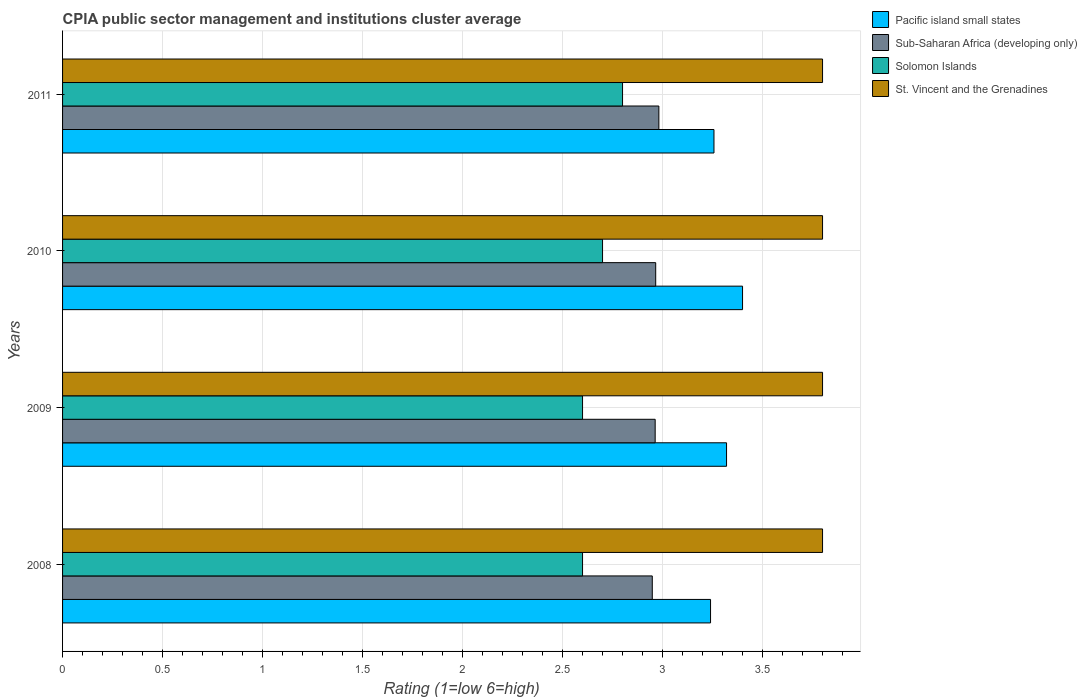How many groups of bars are there?
Your answer should be very brief. 4. Are the number of bars on each tick of the Y-axis equal?
Your response must be concise. Yes. How many bars are there on the 2nd tick from the bottom?
Ensure brevity in your answer.  4. What is the label of the 3rd group of bars from the top?
Offer a terse response. 2009. In how many cases, is the number of bars for a given year not equal to the number of legend labels?
Make the answer very short. 0. What is the CPIA rating in Solomon Islands in 2009?
Ensure brevity in your answer.  2.6. Across all years, what is the maximum CPIA rating in Solomon Islands?
Offer a very short reply. 2.8. Across all years, what is the minimum CPIA rating in Sub-Saharan Africa (developing only)?
Ensure brevity in your answer.  2.95. In which year was the CPIA rating in St. Vincent and the Grenadines minimum?
Keep it short and to the point. 2008. What is the total CPIA rating in Sub-Saharan Africa (developing only) in the graph?
Give a very brief answer. 11.86. What is the difference between the CPIA rating in Sub-Saharan Africa (developing only) in 2009 and that in 2010?
Ensure brevity in your answer.  -0. What is the difference between the CPIA rating in Pacific island small states in 2009 and the CPIA rating in Sub-Saharan Africa (developing only) in 2008?
Give a very brief answer. 0.37. What is the average CPIA rating in Sub-Saharan Africa (developing only) per year?
Your answer should be very brief. 2.96. In the year 2009, what is the difference between the CPIA rating in Pacific island small states and CPIA rating in Solomon Islands?
Your response must be concise. 0.72. What is the ratio of the CPIA rating in Solomon Islands in 2009 to that in 2010?
Give a very brief answer. 0.96. Is the difference between the CPIA rating in Pacific island small states in 2010 and 2011 greater than the difference between the CPIA rating in Solomon Islands in 2010 and 2011?
Your response must be concise. Yes. What is the difference between the highest and the second highest CPIA rating in Pacific island small states?
Keep it short and to the point. 0.08. What is the difference between the highest and the lowest CPIA rating in St. Vincent and the Grenadines?
Your response must be concise. 0. Is the sum of the CPIA rating in Pacific island small states in 2009 and 2010 greater than the maximum CPIA rating in Sub-Saharan Africa (developing only) across all years?
Your answer should be very brief. Yes. What does the 3rd bar from the top in 2010 represents?
Give a very brief answer. Sub-Saharan Africa (developing only). What does the 3rd bar from the bottom in 2009 represents?
Make the answer very short. Solomon Islands. Is it the case that in every year, the sum of the CPIA rating in Sub-Saharan Africa (developing only) and CPIA rating in St. Vincent and the Grenadines is greater than the CPIA rating in Pacific island small states?
Give a very brief answer. Yes. How many bars are there?
Provide a short and direct response. 16. Are all the bars in the graph horizontal?
Give a very brief answer. Yes. How many years are there in the graph?
Your response must be concise. 4. What is the difference between two consecutive major ticks on the X-axis?
Provide a succinct answer. 0.5. Does the graph contain grids?
Keep it short and to the point. Yes. How are the legend labels stacked?
Provide a succinct answer. Vertical. What is the title of the graph?
Your answer should be very brief. CPIA public sector management and institutions cluster average. What is the label or title of the Y-axis?
Keep it short and to the point. Years. What is the Rating (1=low 6=high) in Pacific island small states in 2008?
Your answer should be compact. 3.24. What is the Rating (1=low 6=high) in Sub-Saharan Africa (developing only) in 2008?
Make the answer very short. 2.95. What is the Rating (1=low 6=high) of Solomon Islands in 2008?
Make the answer very short. 2.6. What is the Rating (1=low 6=high) in St. Vincent and the Grenadines in 2008?
Provide a succinct answer. 3.8. What is the Rating (1=low 6=high) in Pacific island small states in 2009?
Your response must be concise. 3.32. What is the Rating (1=low 6=high) in Sub-Saharan Africa (developing only) in 2009?
Provide a short and direct response. 2.96. What is the Rating (1=low 6=high) of St. Vincent and the Grenadines in 2009?
Your response must be concise. 3.8. What is the Rating (1=low 6=high) in Pacific island small states in 2010?
Give a very brief answer. 3.4. What is the Rating (1=low 6=high) in Sub-Saharan Africa (developing only) in 2010?
Your answer should be very brief. 2.97. What is the Rating (1=low 6=high) of St. Vincent and the Grenadines in 2010?
Your answer should be compact. 3.8. What is the Rating (1=low 6=high) in Pacific island small states in 2011?
Provide a short and direct response. 3.26. What is the Rating (1=low 6=high) in Sub-Saharan Africa (developing only) in 2011?
Make the answer very short. 2.98. What is the Rating (1=low 6=high) of Solomon Islands in 2011?
Offer a very short reply. 2.8. Across all years, what is the maximum Rating (1=low 6=high) of Pacific island small states?
Provide a succinct answer. 3.4. Across all years, what is the maximum Rating (1=low 6=high) of Sub-Saharan Africa (developing only)?
Your response must be concise. 2.98. Across all years, what is the maximum Rating (1=low 6=high) in St. Vincent and the Grenadines?
Provide a short and direct response. 3.8. Across all years, what is the minimum Rating (1=low 6=high) of Pacific island small states?
Your answer should be compact. 3.24. Across all years, what is the minimum Rating (1=low 6=high) in Sub-Saharan Africa (developing only)?
Keep it short and to the point. 2.95. Across all years, what is the minimum Rating (1=low 6=high) of St. Vincent and the Grenadines?
Offer a terse response. 3.8. What is the total Rating (1=low 6=high) in Pacific island small states in the graph?
Make the answer very short. 13.22. What is the total Rating (1=low 6=high) in Sub-Saharan Africa (developing only) in the graph?
Make the answer very short. 11.86. What is the total Rating (1=low 6=high) in Solomon Islands in the graph?
Ensure brevity in your answer.  10.7. What is the total Rating (1=low 6=high) in St. Vincent and the Grenadines in the graph?
Provide a succinct answer. 15.2. What is the difference between the Rating (1=low 6=high) in Pacific island small states in 2008 and that in 2009?
Keep it short and to the point. -0.08. What is the difference between the Rating (1=low 6=high) of Sub-Saharan Africa (developing only) in 2008 and that in 2009?
Your answer should be compact. -0.01. What is the difference between the Rating (1=low 6=high) in Pacific island small states in 2008 and that in 2010?
Offer a very short reply. -0.16. What is the difference between the Rating (1=low 6=high) of Sub-Saharan Africa (developing only) in 2008 and that in 2010?
Offer a terse response. -0.02. What is the difference between the Rating (1=low 6=high) of Solomon Islands in 2008 and that in 2010?
Provide a succinct answer. -0.1. What is the difference between the Rating (1=low 6=high) of Pacific island small states in 2008 and that in 2011?
Make the answer very short. -0.02. What is the difference between the Rating (1=low 6=high) of Sub-Saharan Africa (developing only) in 2008 and that in 2011?
Your answer should be very brief. -0.03. What is the difference between the Rating (1=low 6=high) of St. Vincent and the Grenadines in 2008 and that in 2011?
Ensure brevity in your answer.  0. What is the difference between the Rating (1=low 6=high) in Pacific island small states in 2009 and that in 2010?
Provide a short and direct response. -0.08. What is the difference between the Rating (1=low 6=high) of Sub-Saharan Africa (developing only) in 2009 and that in 2010?
Your answer should be very brief. -0. What is the difference between the Rating (1=low 6=high) of Solomon Islands in 2009 and that in 2010?
Provide a succinct answer. -0.1. What is the difference between the Rating (1=low 6=high) of St. Vincent and the Grenadines in 2009 and that in 2010?
Your response must be concise. 0. What is the difference between the Rating (1=low 6=high) of Pacific island small states in 2009 and that in 2011?
Provide a short and direct response. 0.06. What is the difference between the Rating (1=low 6=high) in Sub-Saharan Africa (developing only) in 2009 and that in 2011?
Provide a succinct answer. -0.02. What is the difference between the Rating (1=low 6=high) of St. Vincent and the Grenadines in 2009 and that in 2011?
Your answer should be very brief. 0. What is the difference between the Rating (1=low 6=high) in Pacific island small states in 2010 and that in 2011?
Offer a terse response. 0.14. What is the difference between the Rating (1=low 6=high) of Sub-Saharan Africa (developing only) in 2010 and that in 2011?
Give a very brief answer. -0.02. What is the difference between the Rating (1=low 6=high) of Solomon Islands in 2010 and that in 2011?
Make the answer very short. -0.1. What is the difference between the Rating (1=low 6=high) in Pacific island small states in 2008 and the Rating (1=low 6=high) in Sub-Saharan Africa (developing only) in 2009?
Provide a short and direct response. 0.28. What is the difference between the Rating (1=low 6=high) of Pacific island small states in 2008 and the Rating (1=low 6=high) of Solomon Islands in 2009?
Offer a terse response. 0.64. What is the difference between the Rating (1=low 6=high) in Pacific island small states in 2008 and the Rating (1=low 6=high) in St. Vincent and the Grenadines in 2009?
Provide a succinct answer. -0.56. What is the difference between the Rating (1=low 6=high) of Sub-Saharan Africa (developing only) in 2008 and the Rating (1=low 6=high) of Solomon Islands in 2009?
Your answer should be very brief. 0.35. What is the difference between the Rating (1=low 6=high) of Sub-Saharan Africa (developing only) in 2008 and the Rating (1=low 6=high) of St. Vincent and the Grenadines in 2009?
Your response must be concise. -0.85. What is the difference between the Rating (1=low 6=high) in Solomon Islands in 2008 and the Rating (1=low 6=high) in St. Vincent and the Grenadines in 2009?
Your response must be concise. -1.2. What is the difference between the Rating (1=low 6=high) of Pacific island small states in 2008 and the Rating (1=low 6=high) of Sub-Saharan Africa (developing only) in 2010?
Give a very brief answer. 0.27. What is the difference between the Rating (1=low 6=high) in Pacific island small states in 2008 and the Rating (1=low 6=high) in Solomon Islands in 2010?
Provide a succinct answer. 0.54. What is the difference between the Rating (1=low 6=high) of Pacific island small states in 2008 and the Rating (1=low 6=high) of St. Vincent and the Grenadines in 2010?
Give a very brief answer. -0.56. What is the difference between the Rating (1=low 6=high) in Sub-Saharan Africa (developing only) in 2008 and the Rating (1=low 6=high) in Solomon Islands in 2010?
Offer a terse response. 0.25. What is the difference between the Rating (1=low 6=high) in Sub-Saharan Africa (developing only) in 2008 and the Rating (1=low 6=high) in St. Vincent and the Grenadines in 2010?
Keep it short and to the point. -0.85. What is the difference between the Rating (1=low 6=high) of Pacific island small states in 2008 and the Rating (1=low 6=high) of Sub-Saharan Africa (developing only) in 2011?
Give a very brief answer. 0.26. What is the difference between the Rating (1=low 6=high) in Pacific island small states in 2008 and the Rating (1=low 6=high) in Solomon Islands in 2011?
Make the answer very short. 0.44. What is the difference between the Rating (1=low 6=high) of Pacific island small states in 2008 and the Rating (1=low 6=high) of St. Vincent and the Grenadines in 2011?
Your answer should be very brief. -0.56. What is the difference between the Rating (1=low 6=high) in Sub-Saharan Africa (developing only) in 2008 and the Rating (1=low 6=high) in Solomon Islands in 2011?
Offer a very short reply. 0.15. What is the difference between the Rating (1=low 6=high) of Sub-Saharan Africa (developing only) in 2008 and the Rating (1=low 6=high) of St. Vincent and the Grenadines in 2011?
Provide a short and direct response. -0.85. What is the difference between the Rating (1=low 6=high) of Solomon Islands in 2008 and the Rating (1=low 6=high) of St. Vincent and the Grenadines in 2011?
Your answer should be very brief. -1.2. What is the difference between the Rating (1=low 6=high) in Pacific island small states in 2009 and the Rating (1=low 6=high) in Sub-Saharan Africa (developing only) in 2010?
Keep it short and to the point. 0.35. What is the difference between the Rating (1=low 6=high) of Pacific island small states in 2009 and the Rating (1=low 6=high) of Solomon Islands in 2010?
Make the answer very short. 0.62. What is the difference between the Rating (1=low 6=high) of Pacific island small states in 2009 and the Rating (1=low 6=high) of St. Vincent and the Grenadines in 2010?
Provide a succinct answer. -0.48. What is the difference between the Rating (1=low 6=high) of Sub-Saharan Africa (developing only) in 2009 and the Rating (1=low 6=high) of Solomon Islands in 2010?
Make the answer very short. 0.26. What is the difference between the Rating (1=low 6=high) in Sub-Saharan Africa (developing only) in 2009 and the Rating (1=low 6=high) in St. Vincent and the Grenadines in 2010?
Provide a succinct answer. -0.84. What is the difference between the Rating (1=low 6=high) in Pacific island small states in 2009 and the Rating (1=low 6=high) in Sub-Saharan Africa (developing only) in 2011?
Make the answer very short. 0.34. What is the difference between the Rating (1=low 6=high) in Pacific island small states in 2009 and the Rating (1=low 6=high) in Solomon Islands in 2011?
Ensure brevity in your answer.  0.52. What is the difference between the Rating (1=low 6=high) of Pacific island small states in 2009 and the Rating (1=low 6=high) of St. Vincent and the Grenadines in 2011?
Your answer should be compact. -0.48. What is the difference between the Rating (1=low 6=high) in Sub-Saharan Africa (developing only) in 2009 and the Rating (1=low 6=high) in Solomon Islands in 2011?
Make the answer very short. 0.16. What is the difference between the Rating (1=low 6=high) of Sub-Saharan Africa (developing only) in 2009 and the Rating (1=low 6=high) of St. Vincent and the Grenadines in 2011?
Provide a short and direct response. -0.84. What is the difference between the Rating (1=low 6=high) in Solomon Islands in 2009 and the Rating (1=low 6=high) in St. Vincent and the Grenadines in 2011?
Make the answer very short. -1.2. What is the difference between the Rating (1=low 6=high) of Pacific island small states in 2010 and the Rating (1=low 6=high) of Sub-Saharan Africa (developing only) in 2011?
Make the answer very short. 0.42. What is the difference between the Rating (1=low 6=high) in Pacific island small states in 2010 and the Rating (1=low 6=high) in Solomon Islands in 2011?
Your answer should be very brief. 0.6. What is the difference between the Rating (1=low 6=high) of Pacific island small states in 2010 and the Rating (1=low 6=high) of St. Vincent and the Grenadines in 2011?
Offer a terse response. -0.4. What is the difference between the Rating (1=low 6=high) of Sub-Saharan Africa (developing only) in 2010 and the Rating (1=low 6=high) of Solomon Islands in 2011?
Offer a very short reply. 0.17. What is the difference between the Rating (1=low 6=high) in Sub-Saharan Africa (developing only) in 2010 and the Rating (1=low 6=high) in St. Vincent and the Grenadines in 2011?
Give a very brief answer. -0.83. What is the average Rating (1=low 6=high) in Pacific island small states per year?
Offer a very short reply. 3.3. What is the average Rating (1=low 6=high) of Sub-Saharan Africa (developing only) per year?
Offer a very short reply. 2.96. What is the average Rating (1=low 6=high) of Solomon Islands per year?
Make the answer very short. 2.67. What is the average Rating (1=low 6=high) in St. Vincent and the Grenadines per year?
Your answer should be compact. 3.8. In the year 2008, what is the difference between the Rating (1=low 6=high) of Pacific island small states and Rating (1=low 6=high) of Sub-Saharan Africa (developing only)?
Make the answer very short. 0.29. In the year 2008, what is the difference between the Rating (1=low 6=high) of Pacific island small states and Rating (1=low 6=high) of Solomon Islands?
Your answer should be compact. 0.64. In the year 2008, what is the difference between the Rating (1=low 6=high) in Pacific island small states and Rating (1=low 6=high) in St. Vincent and the Grenadines?
Make the answer very short. -0.56. In the year 2008, what is the difference between the Rating (1=low 6=high) in Sub-Saharan Africa (developing only) and Rating (1=low 6=high) in Solomon Islands?
Keep it short and to the point. 0.35. In the year 2008, what is the difference between the Rating (1=low 6=high) in Sub-Saharan Africa (developing only) and Rating (1=low 6=high) in St. Vincent and the Grenadines?
Your answer should be very brief. -0.85. In the year 2009, what is the difference between the Rating (1=low 6=high) in Pacific island small states and Rating (1=low 6=high) in Sub-Saharan Africa (developing only)?
Ensure brevity in your answer.  0.36. In the year 2009, what is the difference between the Rating (1=low 6=high) in Pacific island small states and Rating (1=low 6=high) in Solomon Islands?
Provide a succinct answer. 0.72. In the year 2009, what is the difference between the Rating (1=low 6=high) in Pacific island small states and Rating (1=low 6=high) in St. Vincent and the Grenadines?
Make the answer very short. -0.48. In the year 2009, what is the difference between the Rating (1=low 6=high) in Sub-Saharan Africa (developing only) and Rating (1=low 6=high) in Solomon Islands?
Offer a terse response. 0.36. In the year 2009, what is the difference between the Rating (1=low 6=high) of Sub-Saharan Africa (developing only) and Rating (1=low 6=high) of St. Vincent and the Grenadines?
Ensure brevity in your answer.  -0.84. In the year 2010, what is the difference between the Rating (1=low 6=high) of Pacific island small states and Rating (1=low 6=high) of Sub-Saharan Africa (developing only)?
Give a very brief answer. 0.43. In the year 2010, what is the difference between the Rating (1=low 6=high) in Pacific island small states and Rating (1=low 6=high) in Solomon Islands?
Offer a very short reply. 0.7. In the year 2010, what is the difference between the Rating (1=low 6=high) of Sub-Saharan Africa (developing only) and Rating (1=low 6=high) of Solomon Islands?
Offer a terse response. 0.27. In the year 2010, what is the difference between the Rating (1=low 6=high) in Sub-Saharan Africa (developing only) and Rating (1=low 6=high) in St. Vincent and the Grenadines?
Keep it short and to the point. -0.83. In the year 2010, what is the difference between the Rating (1=low 6=high) in Solomon Islands and Rating (1=low 6=high) in St. Vincent and the Grenadines?
Provide a short and direct response. -1.1. In the year 2011, what is the difference between the Rating (1=low 6=high) in Pacific island small states and Rating (1=low 6=high) in Sub-Saharan Africa (developing only)?
Make the answer very short. 0.28. In the year 2011, what is the difference between the Rating (1=low 6=high) in Pacific island small states and Rating (1=low 6=high) in Solomon Islands?
Your answer should be very brief. 0.46. In the year 2011, what is the difference between the Rating (1=low 6=high) in Pacific island small states and Rating (1=low 6=high) in St. Vincent and the Grenadines?
Make the answer very short. -0.54. In the year 2011, what is the difference between the Rating (1=low 6=high) in Sub-Saharan Africa (developing only) and Rating (1=low 6=high) in Solomon Islands?
Your response must be concise. 0.18. In the year 2011, what is the difference between the Rating (1=low 6=high) in Sub-Saharan Africa (developing only) and Rating (1=low 6=high) in St. Vincent and the Grenadines?
Provide a short and direct response. -0.82. In the year 2011, what is the difference between the Rating (1=low 6=high) in Solomon Islands and Rating (1=low 6=high) in St. Vincent and the Grenadines?
Provide a short and direct response. -1. What is the ratio of the Rating (1=low 6=high) of Pacific island small states in 2008 to that in 2009?
Ensure brevity in your answer.  0.98. What is the ratio of the Rating (1=low 6=high) of Pacific island small states in 2008 to that in 2010?
Provide a short and direct response. 0.95. What is the ratio of the Rating (1=low 6=high) of St. Vincent and the Grenadines in 2008 to that in 2010?
Keep it short and to the point. 1. What is the ratio of the Rating (1=low 6=high) of Pacific island small states in 2008 to that in 2011?
Your answer should be compact. 0.99. What is the ratio of the Rating (1=low 6=high) of Solomon Islands in 2008 to that in 2011?
Make the answer very short. 0.93. What is the ratio of the Rating (1=low 6=high) in Pacific island small states in 2009 to that in 2010?
Make the answer very short. 0.98. What is the ratio of the Rating (1=low 6=high) of Pacific island small states in 2009 to that in 2011?
Give a very brief answer. 1.02. What is the ratio of the Rating (1=low 6=high) in Sub-Saharan Africa (developing only) in 2009 to that in 2011?
Ensure brevity in your answer.  0.99. What is the ratio of the Rating (1=low 6=high) of Pacific island small states in 2010 to that in 2011?
Keep it short and to the point. 1.04. What is the difference between the highest and the second highest Rating (1=low 6=high) in Sub-Saharan Africa (developing only)?
Your answer should be very brief. 0.02. What is the difference between the highest and the second highest Rating (1=low 6=high) in Solomon Islands?
Provide a succinct answer. 0.1. What is the difference between the highest and the second highest Rating (1=low 6=high) of St. Vincent and the Grenadines?
Give a very brief answer. 0. What is the difference between the highest and the lowest Rating (1=low 6=high) in Pacific island small states?
Keep it short and to the point. 0.16. What is the difference between the highest and the lowest Rating (1=low 6=high) in Sub-Saharan Africa (developing only)?
Offer a terse response. 0.03. What is the difference between the highest and the lowest Rating (1=low 6=high) of St. Vincent and the Grenadines?
Your response must be concise. 0. 